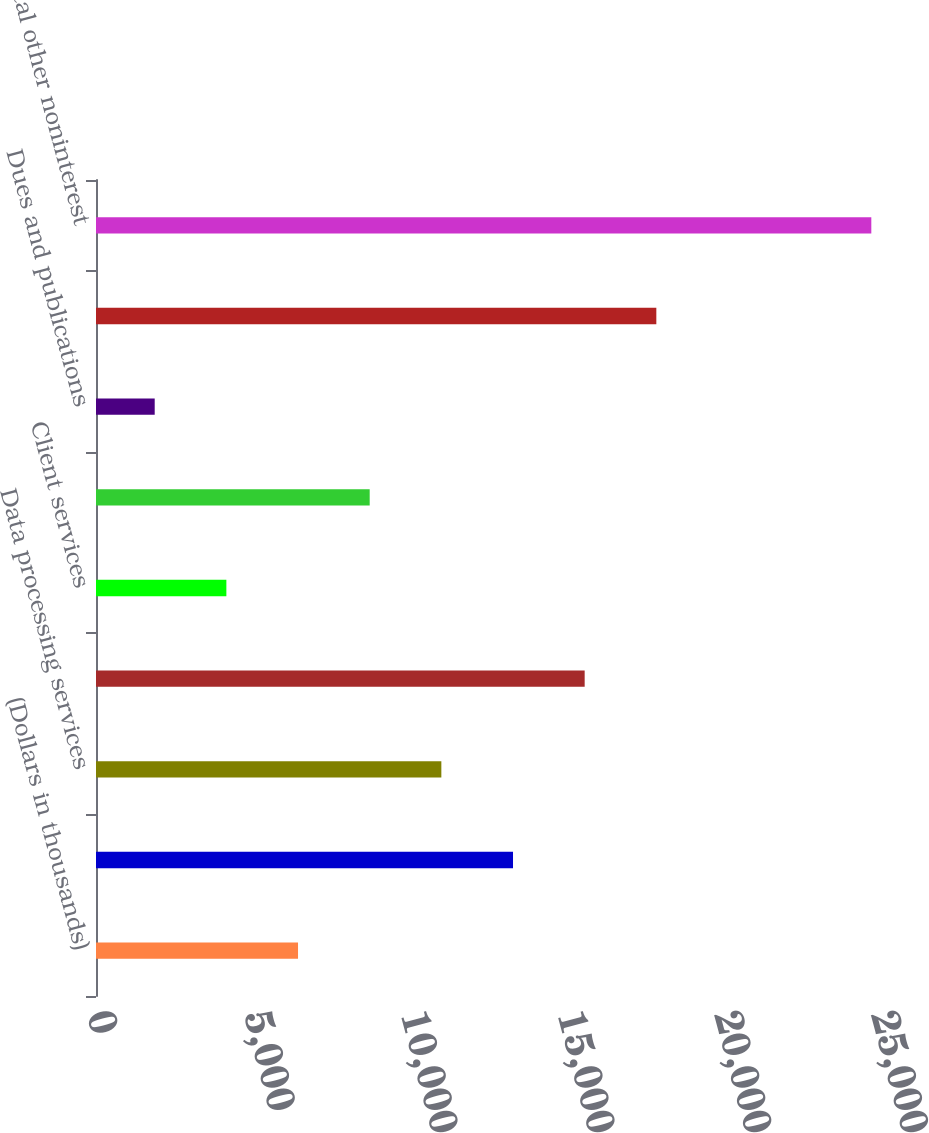Convert chart to OTSL. <chart><loc_0><loc_0><loc_500><loc_500><bar_chart><fcel>(Dollars in thousands)<fcel>Telephone<fcel>Data processing services<fcel>Tax credit fund amortization<fcel>Client services<fcel>Postage and supplies<fcel>Dues and publications<fcel>Other<fcel>Total other noninterest<nl><fcel>6442.2<fcel>13297.5<fcel>11012.4<fcel>15582.6<fcel>4157.1<fcel>8727.3<fcel>1872<fcel>17867.7<fcel>24723<nl></chart> 